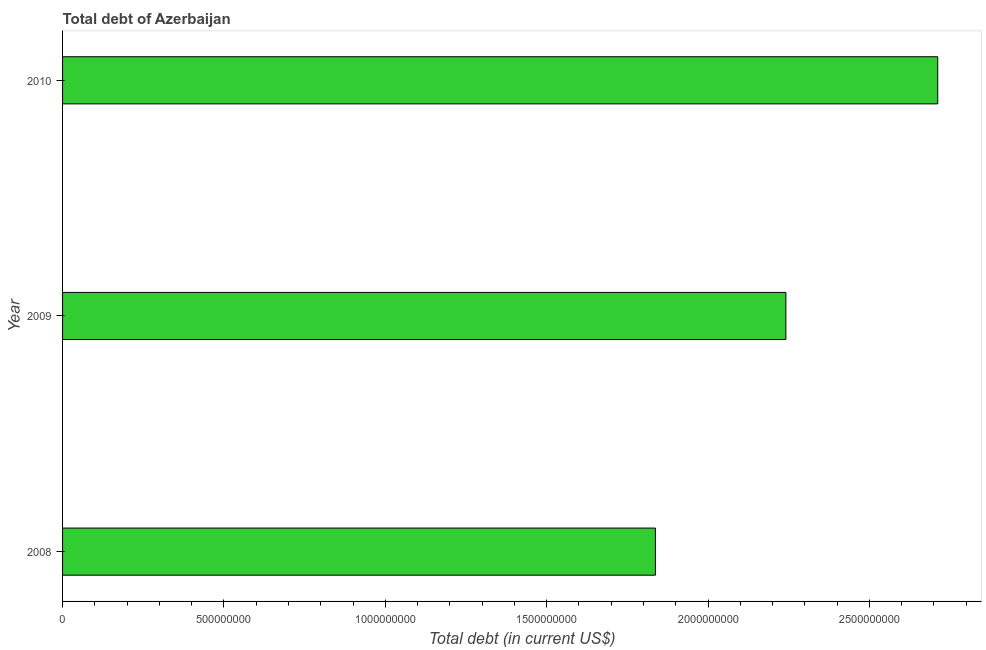Does the graph contain any zero values?
Give a very brief answer. No. Does the graph contain grids?
Your response must be concise. No. What is the title of the graph?
Provide a short and direct response. Total debt of Azerbaijan. What is the label or title of the X-axis?
Make the answer very short. Total debt (in current US$). What is the label or title of the Y-axis?
Give a very brief answer. Year. What is the total debt in 2010?
Your response must be concise. 2.71e+09. Across all years, what is the maximum total debt?
Your answer should be very brief. 2.71e+09. Across all years, what is the minimum total debt?
Give a very brief answer. 1.84e+09. In which year was the total debt minimum?
Offer a very short reply. 2008. What is the sum of the total debt?
Ensure brevity in your answer.  6.79e+09. What is the difference between the total debt in 2009 and 2010?
Provide a short and direct response. -4.71e+08. What is the average total debt per year?
Offer a very short reply. 2.26e+09. What is the median total debt?
Ensure brevity in your answer.  2.24e+09. In how many years, is the total debt greater than 2600000000 US$?
Your response must be concise. 1. What is the ratio of the total debt in 2008 to that in 2010?
Provide a short and direct response. 0.68. What is the difference between the highest and the second highest total debt?
Provide a succinct answer. 4.71e+08. Is the sum of the total debt in 2008 and 2010 greater than the maximum total debt across all years?
Give a very brief answer. Yes. What is the difference between the highest and the lowest total debt?
Give a very brief answer. 8.75e+08. How many bars are there?
Keep it short and to the point. 3. What is the Total debt (in current US$) in 2008?
Your answer should be very brief. 1.84e+09. What is the Total debt (in current US$) of 2009?
Make the answer very short. 2.24e+09. What is the Total debt (in current US$) of 2010?
Keep it short and to the point. 2.71e+09. What is the difference between the Total debt (in current US$) in 2008 and 2009?
Give a very brief answer. -4.04e+08. What is the difference between the Total debt (in current US$) in 2008 and 2010?
Your answer should be very brief. -8.75e+08. What is the difference between the Total debt (in current US$) in 2009 and 2010?
Offer a very short reply. -4.71e+08. What is the ratio of the Total debt (in current US$) in 2008 to that in 2009?
Provide a short and direct response. 0.82. What is the ratio of the Total debt (in current US$) in 2008 to that in 2010?
Provide a succinct answer. 0.68. What is the ratio of the Total debt (in current US$) in 2009 to that in 2010?
Offer a very short reply. 0.83. 